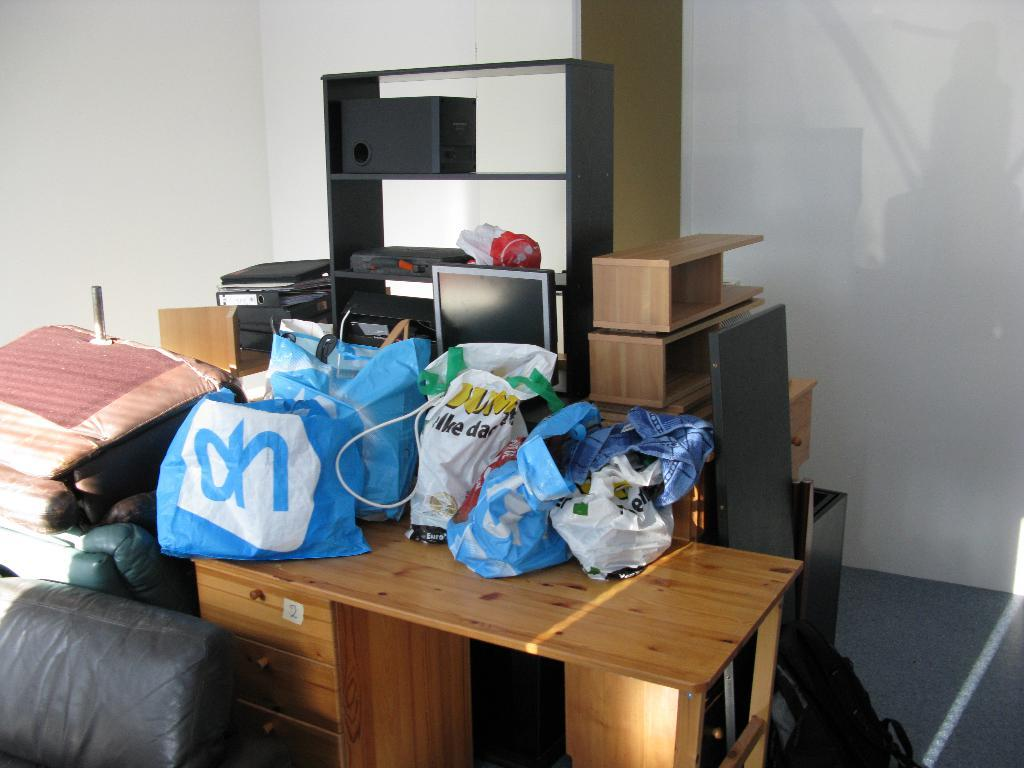<image>
Relay a brief, clear account of the picture shown. A messy room with bags all over a desk, one of which says OH. 